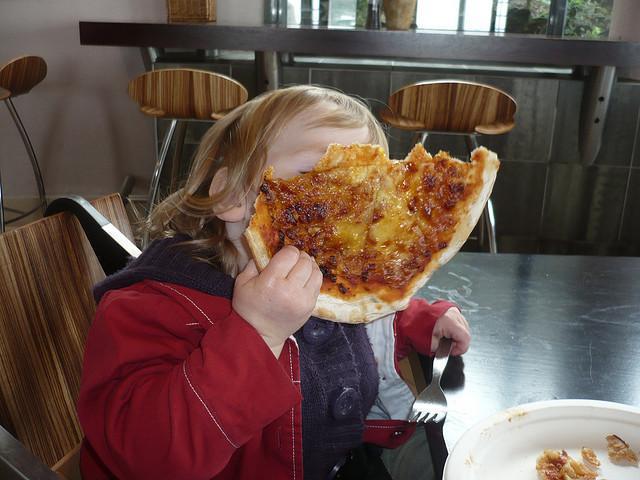Evaluate: Does the caption "The pizza is touching the person." match the image?
Answer yes or no. Yes. 